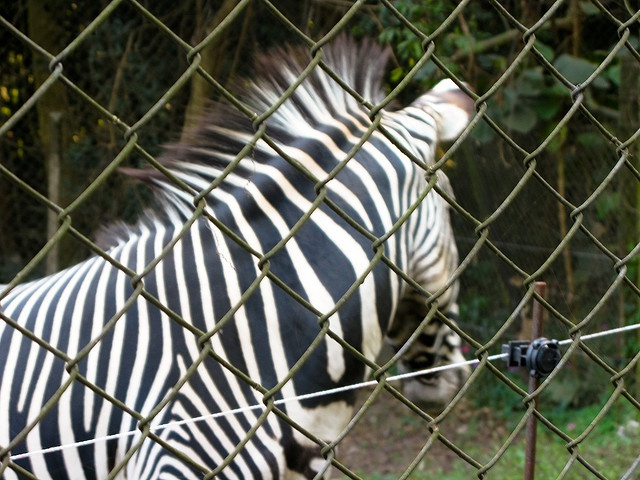Describe the objects in this image and their specific colors. I can see a zebra in black, white, gray, and darkgray tones in this image. 